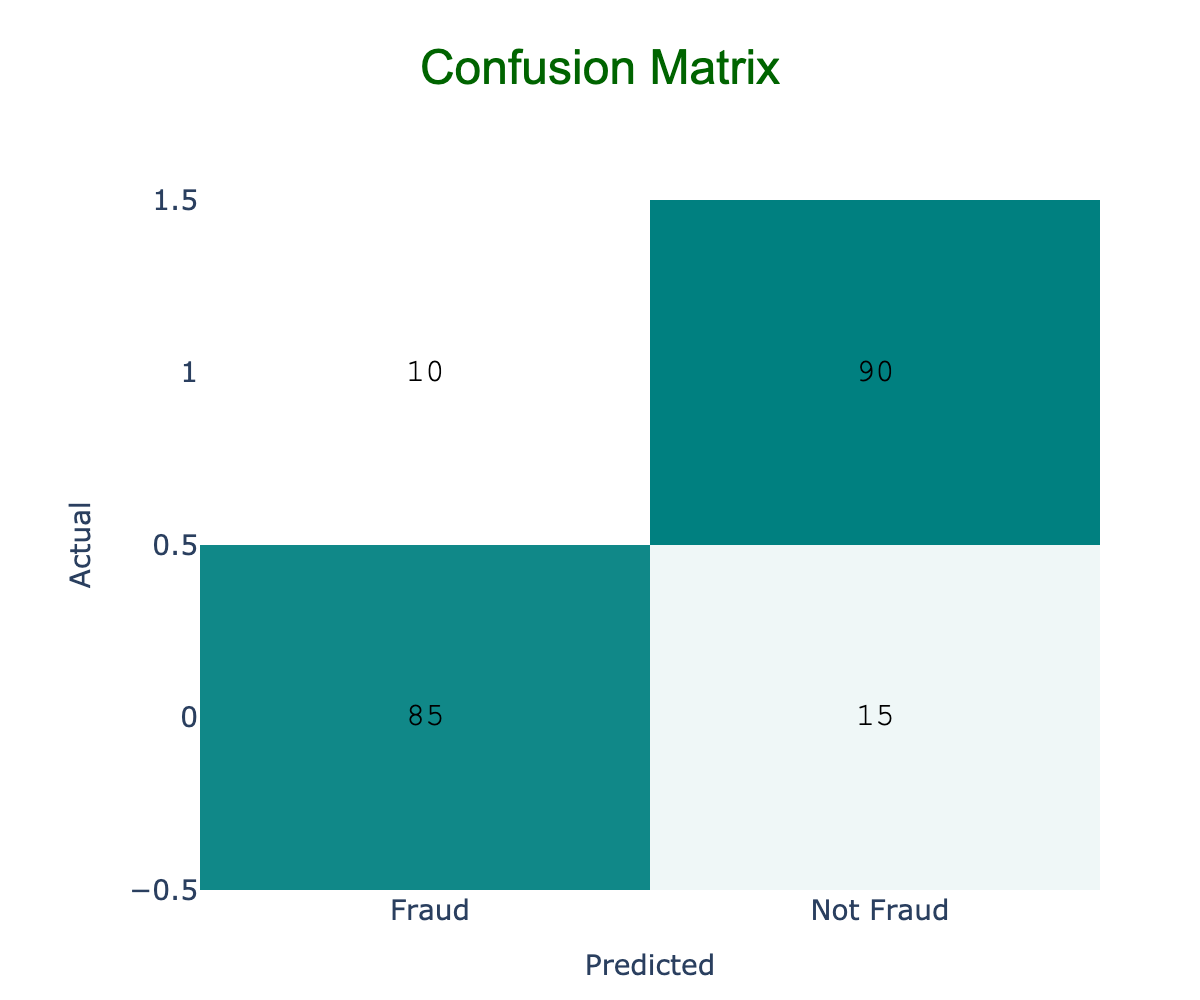What is the total number of actual fraud cases in the confusion matrix? The confusion matrix shows that there are 85 cases of fraud correctly predicted as fraud, and 15 cases incorrectly predicted as not fraud. Thus, the total number of actual fraud cases is 85 + 15 = 100.
Answer: 100 How many instances were incorrectly predicted as fraud? According to the table, there are 10 instances of non-fraud that were incorrectly predicted as fraud. This is observed in the "Not Fraud" row under the "Fraud" column.
Answer: 10 What percentage of actual fraud cases were correctly detected? There are 85 actual cases of fraud that were detected correctly out of a total of 100 actual fraud cases. Therefore, the percentage is (85/100) * 100% = 85%.
Answer: 85% Is the number of cases predicted as not fraud greater than the number of cases predicted as fraud? The total predicted as not fraud is 90 (actual not fraud correctly predicted) + 15 (actual fraud incorrectly predicted) = 105. While the total predicted as fraud is 85 + 10 = 95. Since 105 > 95, the statement is true.
Answer: Yes What is the precision of the fraud detection model? Precision is calculated as the number of true positives divided by the sum of true positives and false positives. Here, precision = 85 / (85 + 10) = 85 / 95 ≈ 0.8947, which is approximately 89.47%.
Answer: 89.47% 